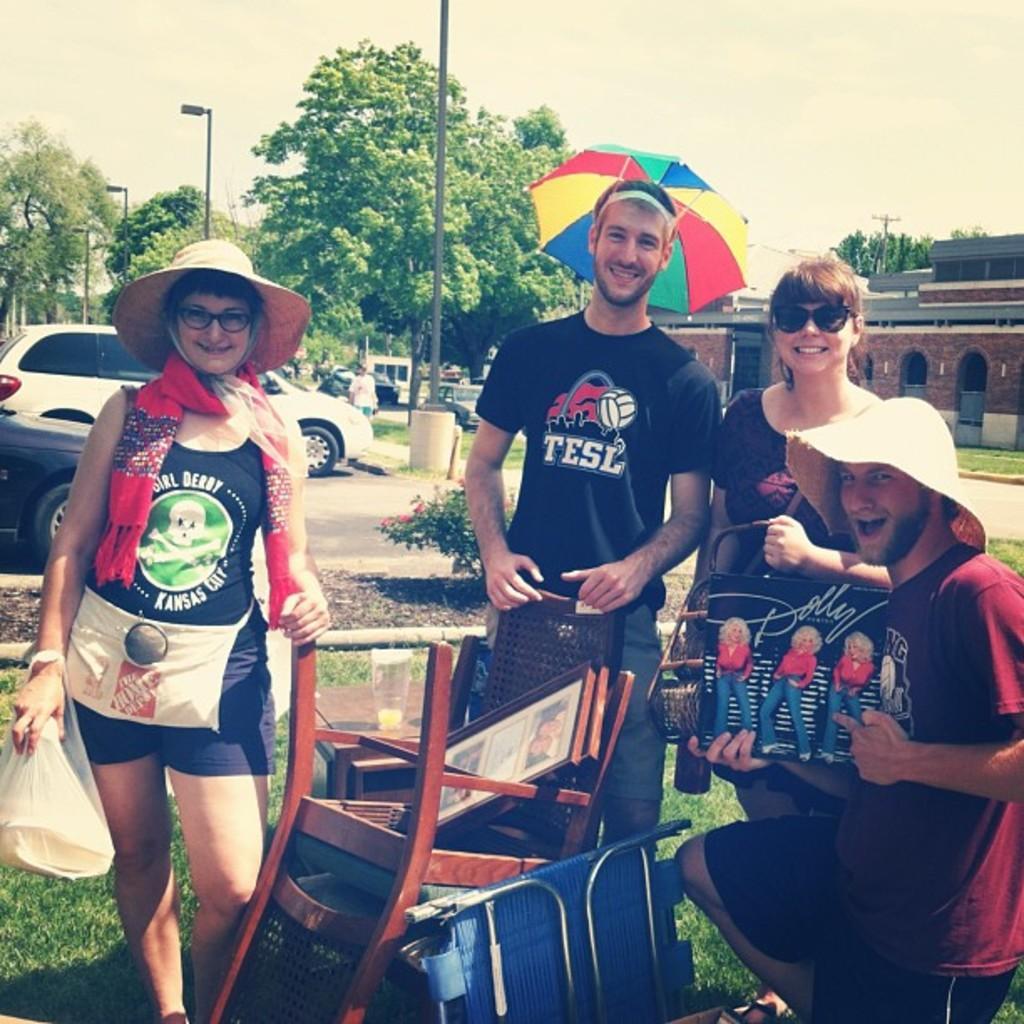Please provide a concise description of this image. In the foreground of this image, there are people standing, holding objects and also a man kneeling down holding a poster like an object. In front them ,there are chairs, frames and a folding chair. behind them, there is a table on which there is a glass. In the background, there are vehicles, a plant, road, buildings, trees, poles and the sky. 